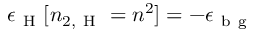<formula> <loc_0><loc_0><loc_500><loc_500>\epsilon _ { H } [ n _ { 2 , H } = n ^ { 2 } ] = - \epsilon _ { b g }</formula> 